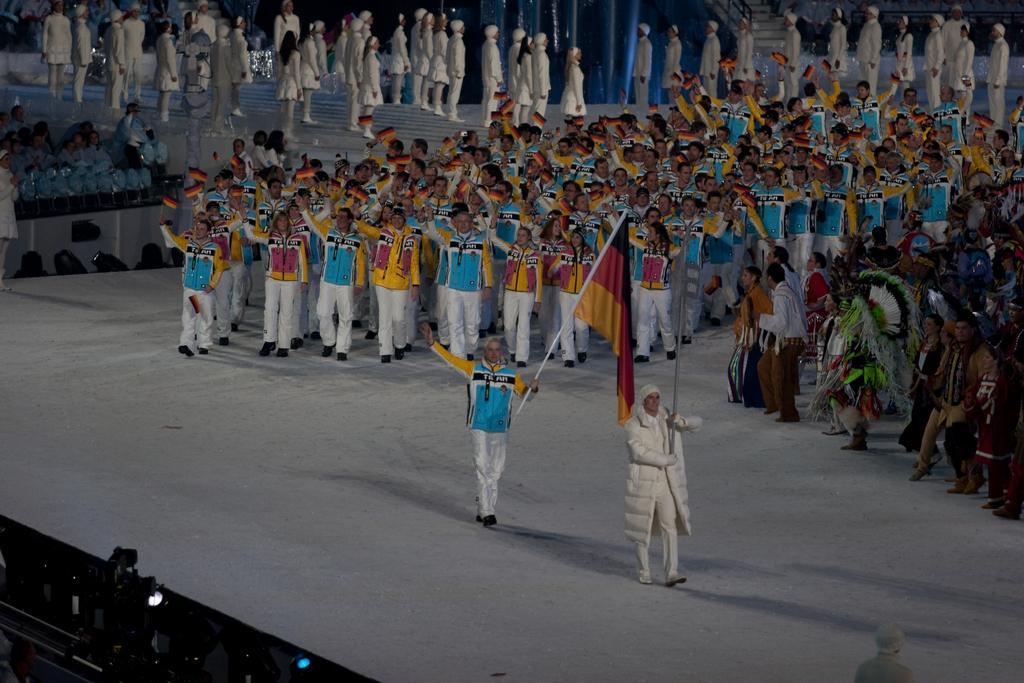Please provide a concise description of this image. This image consists of many people performing march. At the bottom, there is a dais. They are holding rods. In the background, there are many people in white dress. 